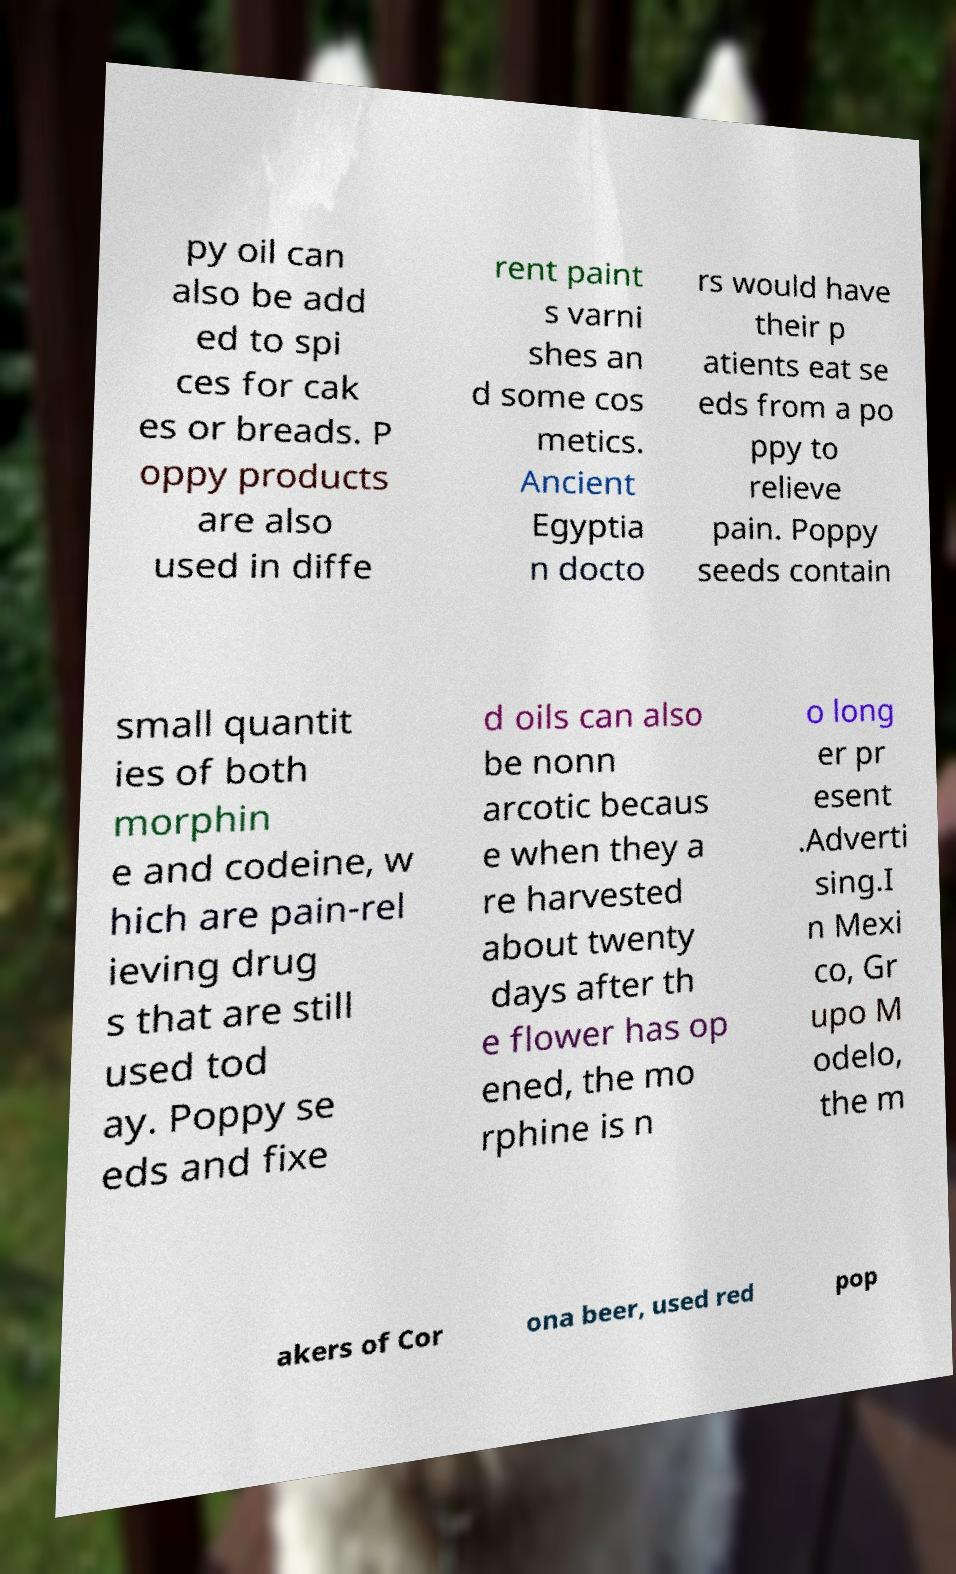I need the written content from this picture converted into text. Can you do that? py oil can also be add ed to spi ces for cak es or breads. P oppy products are also used in diffe rent paint s varni shes an d some cos metics. Ancient Egyptia n docto rs would have their p atients eat se eds from a po ppy to relieve pain. Poppy seeds contain small quantit ies of both morphin e and codeine, w hich are pain-rel ieving drug s that are still used tod ay. Poppy se eds and fixe d oils can also be nonn arcotic becaus e when they a re harvested about twenty days after th e flower has op ened, the mo rphine is n o long er pr esent .Adverti sing.I n Mexi co, Gr upo M odelo, the m akers of Cor ona beer, used red pop 